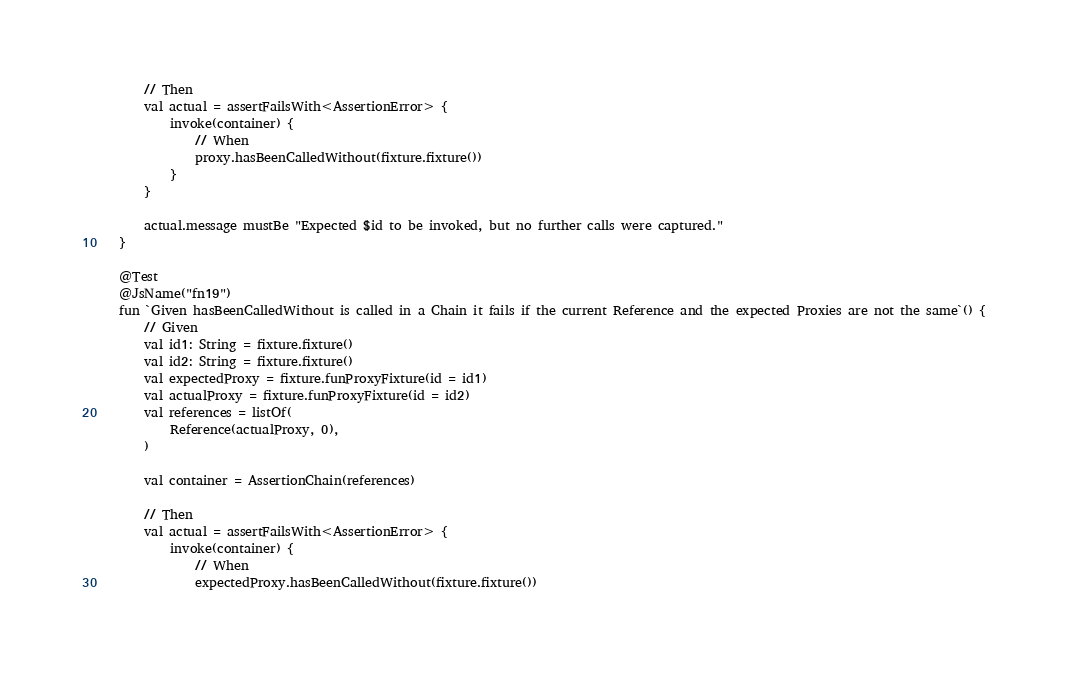<code> <loc_0><loc_0><loc_500><loc_500><_Kotlin_>        // Then
        val actual = assertFailsWith<AssertionError> {
            invoke(container) {
                // When
                proxy.hasBeenCalledWithout(fixture.fixture())
            }
        }

        actual.message mustBe "Expected $id to be invoked, but no further calls were captured."
    }

    @Test
    @JsName("fn19")
    fun `Given hasBeenCalledWithout is called in a Chain it fails if the current Reference and the expected Proxies are not the same`() {
        // Given
        val id1: String = fixture.fixture()
        val id2: String = fixture.fixture()
        val expectedProxy = fixture.funProxyFixture(id = id1)
        val actualProxy = fixture.funProxyFixture(id = id2)
        val references = listOf(
            Reference(actualProxy, 0),
        )

        val container = AssertionChain(references)

        // Then
        val actual = assertFailsWith<AssertionError> {
            invoke(container) {
                // When
                expectedProxy.hasBeenCalledWithout(fixture.fixture())</code> 